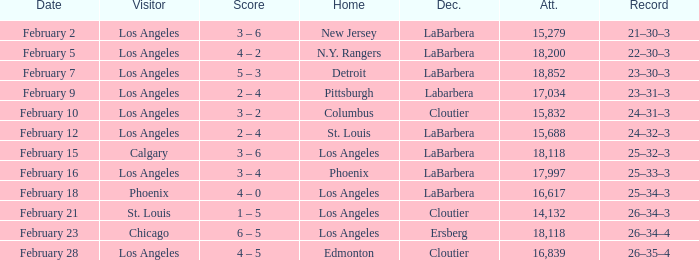What was the decision of the Kings game when Chicago was the visiting team? Ersberg. 